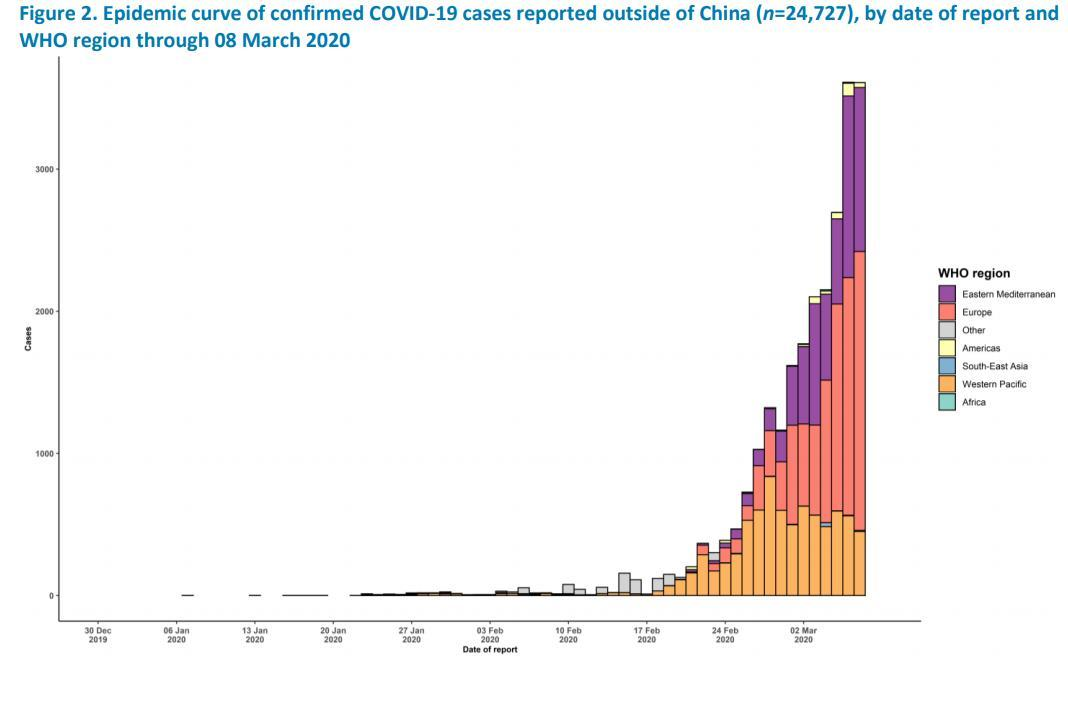Which color is used to represent Eastern mediterranean-green, violet, orange, or yellow?
Answer the question with a short phrase. violet Which color is used to represent Western Pacific-green, red, orange, or yellow? orange 